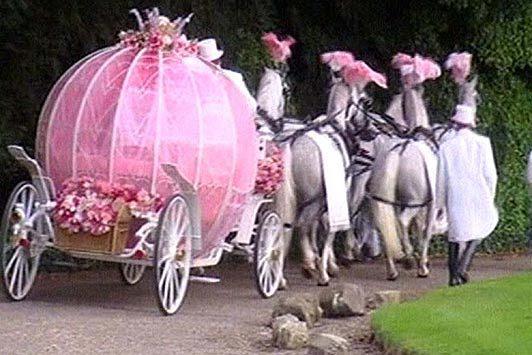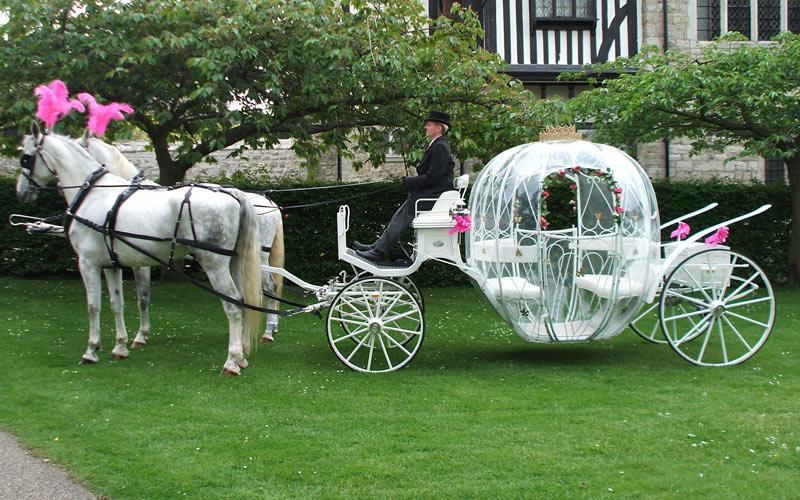The first image is the image on the left, the second image is the image on the right. For the images shown, is this caption "At least two horses in the image on the left have pink head dresses." true? Answer yes or no. Yes. The first image is the image on the left, the second image is the image on the right. Examine the images to the left and right. Is the description "One of the carriages is pulled by a single horse." accurate? Answer yes or no. No. 